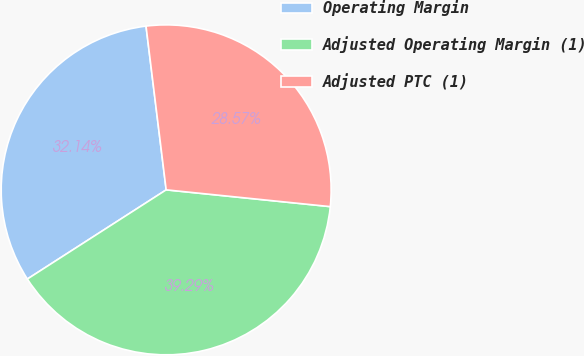Convert chart to OTSL. <chart><loc_0><loc_0><loc_500><loc_500><pie_chart><fcel>Operating Margin<fcel>Adjusted Operating Margin (1)<fcel>Adjusted PTC (1)<nl><fcel>32.14%<fcel>39.29%<fcel>28.57%<nl></chart> 